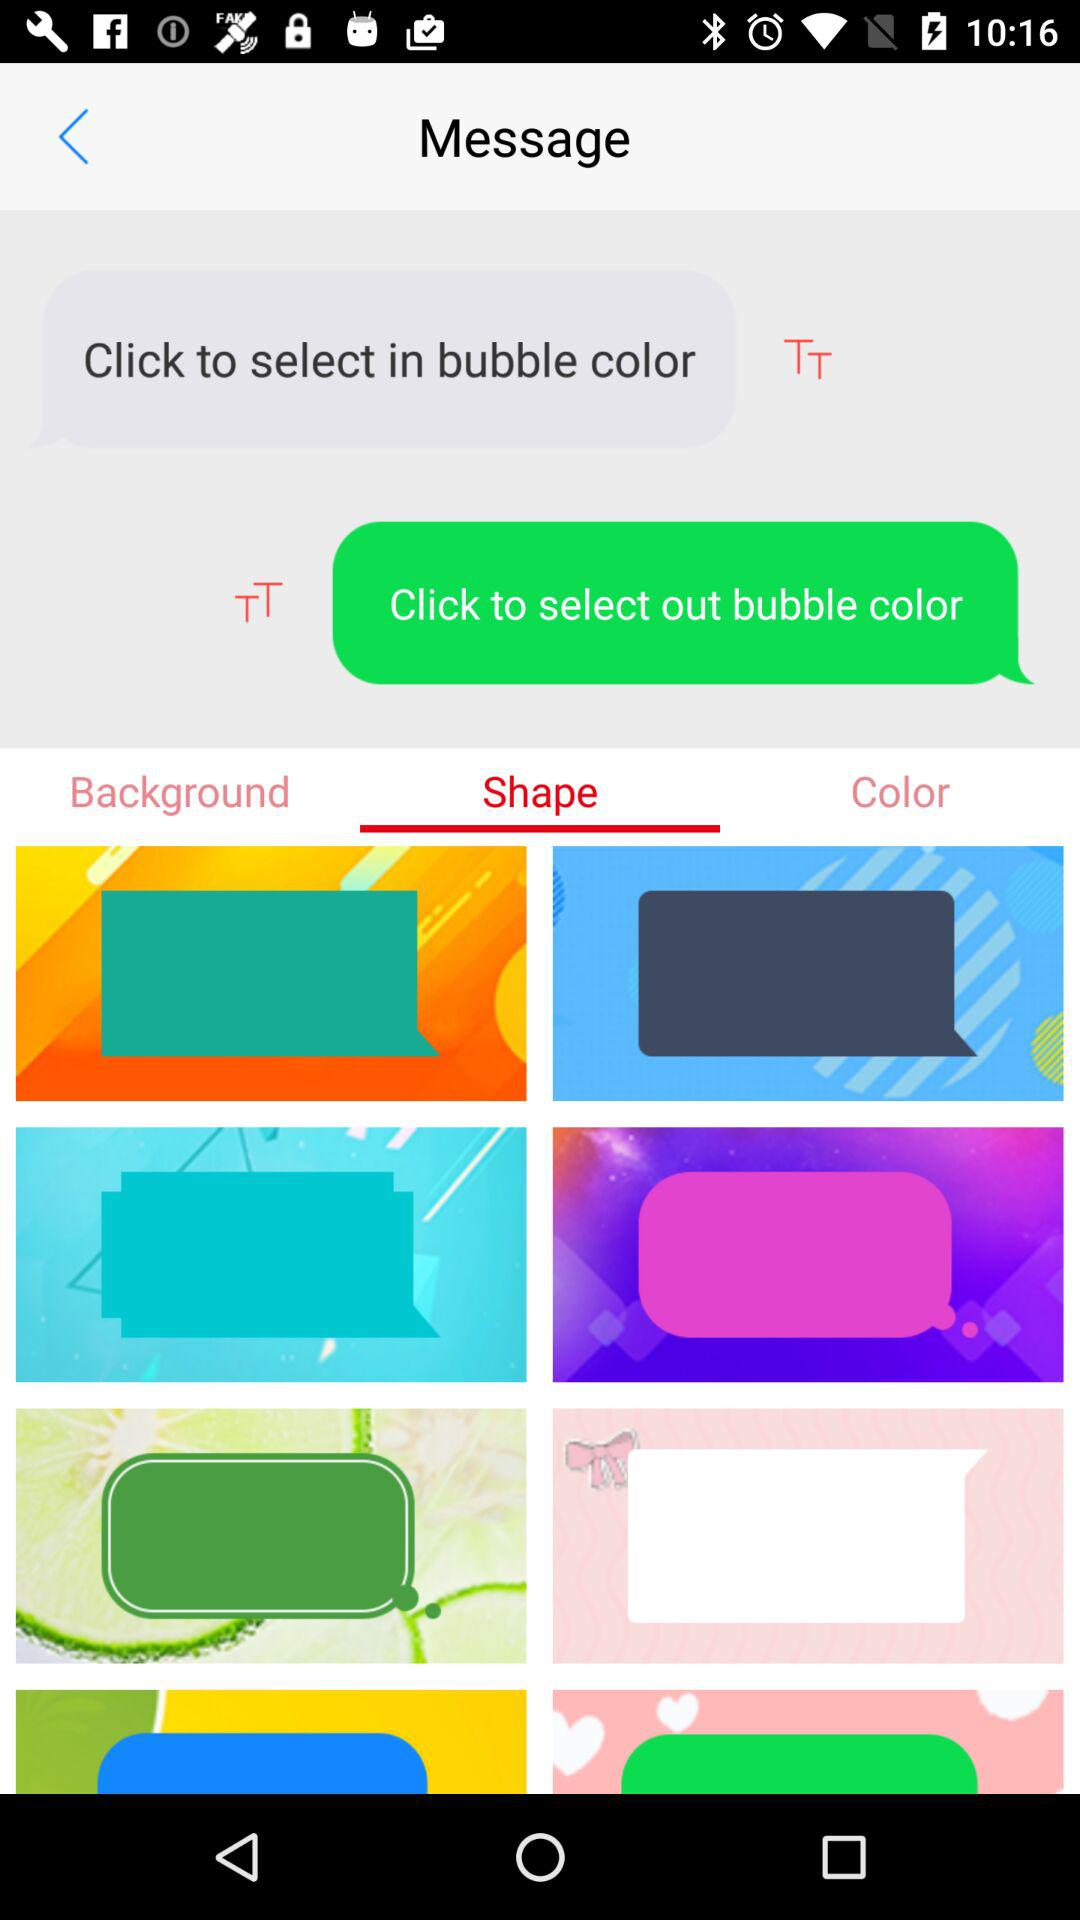What are the available bubble shapes?
When the provided information is insufficient, respond with <no answer>. <no answer> 